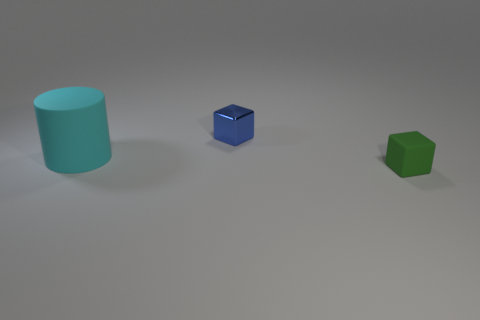Add 2 large blue metal balls. How many objects exist? 5 Subtract all cylinders. How many objects are left? 2 Subtract all small green rubber objects. Subtract all matte blocks. How many objects are left? 1 Add 1 blocks. How many blocks are left? 3 Add 1 small blue shiny things. How many small blue shiny things exist? 2 Subtract 1 blue blocks. How many objects are left? 2 